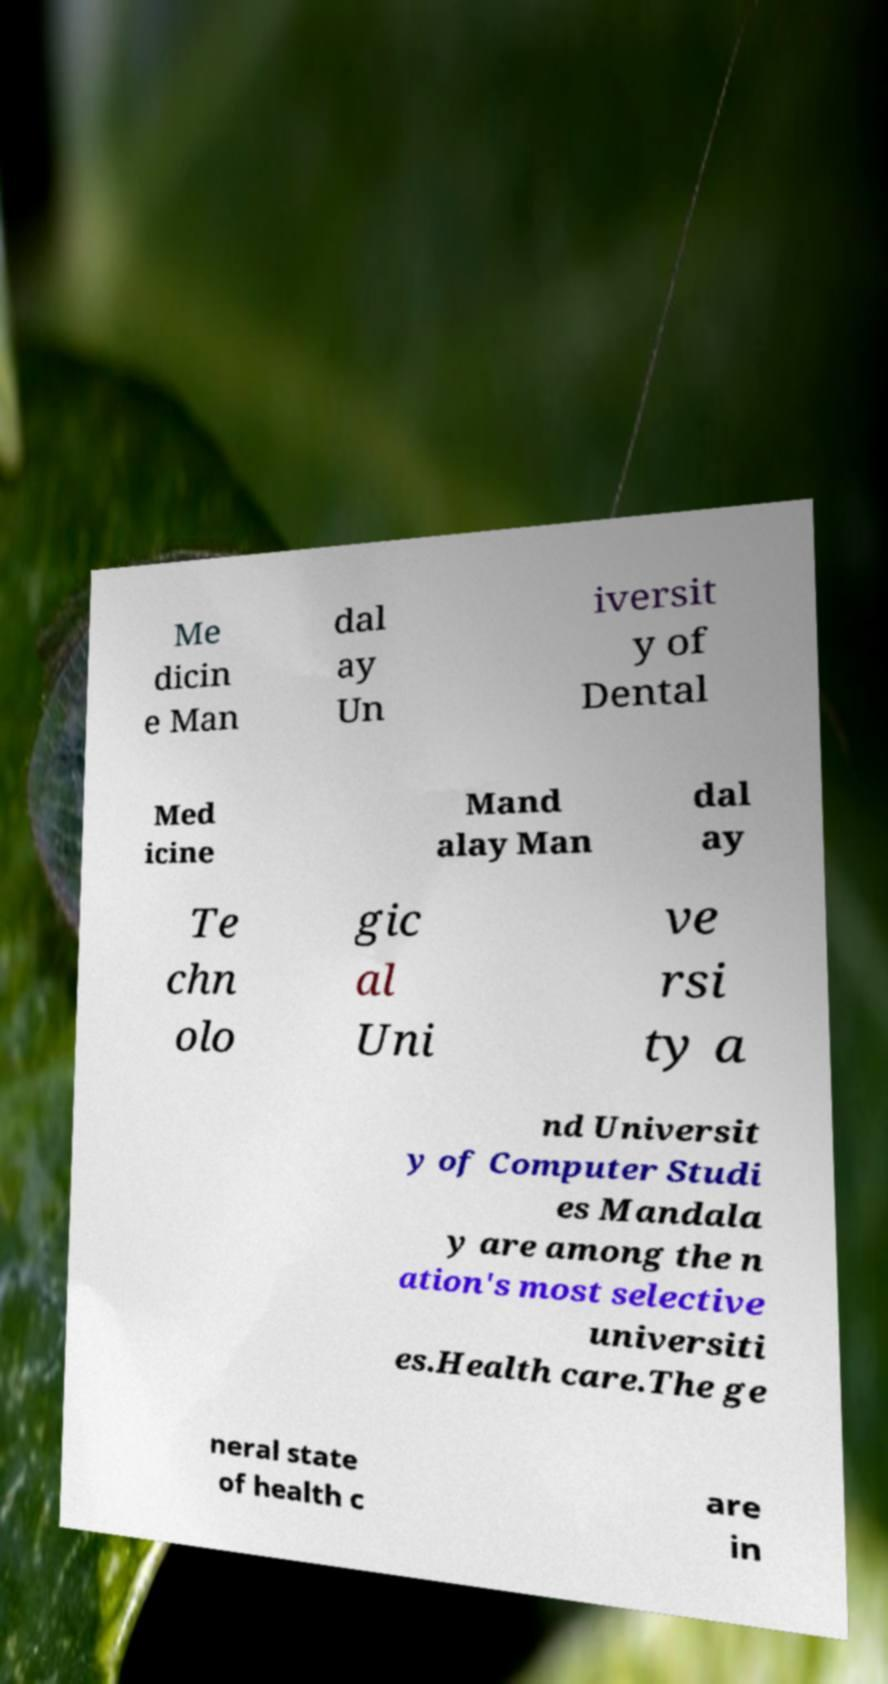Can you accurately transcribe the text from the provided image for me? Me dicin e Man dal ay Un iversit y of Dental Med icine Mand alay Man dal ay Te chn olo gic al Uni ve rsi ty a nd Universit y of Computer Studi es Mandala y are among the n ation's most selective universiti es.Health care.The ge neral state of health c are in 